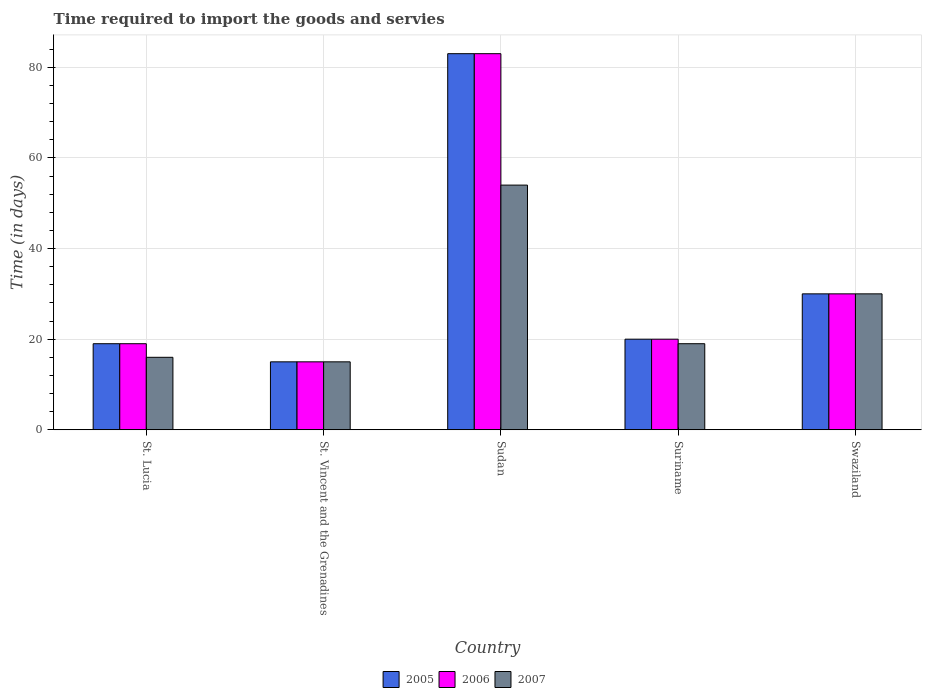How many groups of bars are there?
Your response must be concise. 5. Are the number of bars per tick equal to the number of legend labels?
Offer a very short reply. Yes. How many bars are there on the 5th tick from the left?
Your answer should be compact. 3. What is the label of the 1st group of bars from the left?
Offer a very short reply. St. Lucia. In how many cases, is the number of bars for a given country not equal to the number of legend labels?
Offer a very short reply. 0. What is the number of days required to import the goods and services in 2005 in Suriname?
Give a very brief answer. 20. In which country was the number of days required to import the goods and services in 2005 maximum?
Your answer should be very brief. Sudan. In which country was the number of days required to import the goods and services in 2005 minimum?
Ensure brevity in your answer.  St. Vincent and the Grenadines. What is the total number of days required to import the goods and services in 2006 in the graph?
Provide a succinct answer. 167. What is the difference between the number of days required to import the goods and services in 2006 in Suriname and that in Swaziland?
Give a very brief answer. -10. What is the difference between the number of days required to import the goods and services in 2005 in St. Lucia and the number of days required to import the goods and services in 2007 in Sudan?
Your answer should be compact. -35. What is the average number of days required to import the goods and services in 2005 per country?
Your answer should be compact. 33.4. What is the difference between the number of days required to import the goods and services of/in 2007 and number of days required to import the goods and services of/in 2005 in Sudan?
Your answer should be compact. -29. What is the ratio of the number of days required to import the goods and services in 2005 in St. Vincent and the Grenadines to that in Sudan?
Give a very brief answer. 0.18. Is the number of days required to import the goods and services in 2005 in Sudan less than that in Suriname?
Provide a short and direct response. No. Is the difference between the number of days required to import the goods and services in 2007 in Sudan and Swaziland greater than the difference between the number of days required to import the goods and services in 2005 in Sudan and Swaziland?
Keep it short and to the point. No. What is the difference between the highest and the lowest number of days required to import the goods and services in 2007?
Your answer should be compact. 39. In how many countries, is the number of days required to import the goods and services in 2007 greater than the average number of days required to import the goods and services in 2007 taken over all countries?
Your response must be concise. 2. Is the sum of the number of days required to import the goods and services in 2006 in St. Lucia and Suriname greater than the maximum number of days required to import the goods and services in 2005 across all countries?
Your answer should be compact. No. What does the 3rd bar from the right in Swaziland represents?
Keep it short and to the point. 2005. How many bars are there?
Offer a terse response. 15. Are all the bars in the graph horizontal?
Offer a very short reply. No. How many countries are there in the graph?
Provide a short and direct response. 5. Are the values on the major ticks of Y-axis written in scientific E-notation?
Make the answer very short. No. Does the graph contain any zero values?
Your answer should be compact. No. Where does the legend appear in the graph?
Give a very brief answer. Bottom center. How many legend labels are there?
Your answer should be compact. 3. How are the legend labels stacked?
Keep it short and to the point. Horizontal. What is the title of the graph?
Provide a short and direct response. Time required to import the goods and servies. What is the label or title of the X-axis?
Your answer should be compact. Country. What is the label or title of the Y-axis?
Keep it short and to the point. Time (in days). What is the Time (in days) of 2007 in St. Lucia?
Ensure brevity in your answer.  16. What is the Time (in days) in 2007 in St. Vincent and the Grenadines?
Ensure brevity in your answer.  15. What is the Time (in days) in 2007 in Sudan?
Offer a very short reply. 54. What is the Time (in days) of 2005 in Suriname?
Keep it short and to the point. 20. What is the Time (in days) in 2007 in Suriname?
Ensure brevity in your answer.  19. What is the Time (in days) in 2006 in Swaziland?
Your answer should be compact. 30. Across all countries, what is the maximum Time (in days) of 2005?
Your response must be concise. 83. Across all countries, what is the maximum Time (in days) of 2006?
Ensure brevity in your answer.  83. Across all countries, what is the minimum Time (in days) of 2006?
Make the answer very short. 15. Across all countries, what is the minimum Time (in days) in 2007?
Offer a terse response. 15. What is the total Time (in days) of 2005 in the graph?
Ensure brevity in your answer.  167. What is the total Time (in days) of 2006 in the graph?
Give a very brief answer. 167. What is the total Time (in days) in 2007 in the graph?
Make the answer very short. 134. What is the difference between the Time (in days) in 2005 in St. Lucia and that in Sudan?
Give a very brief answer. -64. What is the difference between the Time (in days) in 2006 in St. Lucia and that in Sudan?
Provide a succinct answer. -64. What is the difference between the Time (in days) in 2007 in St. Lucia and that in Sudan?
Your response must be concise. -38. What is the difference between the Time (in days) of 2005 in St. Lucia and that in Suriname?
Make the answer very short. -1. What is the difference between the Time (in days) of 2006 in St. Lucia and that in Suriname?
Your answer should be compact. -1. What is the difference between the Time (in days) of 2007 in St. Lucia and that in Swaziland?
Keep it short and to the point. -14. What is the difference between the Time (in days) in 2005 in St. Vincent and the Grenadines and that in Sudan?
Provide a succinct answer. -68. What is the difference between the Time (in days) of 2006 in St. Vincent and the Grenadines and that in Sudan?
Ensure brevity in your answer.  -68. What is the difference between the Time (in days) in 2007 in St. Vincent and the Grenadines and that in Sudan?
Keep it short and to the point. -39. What is the difference between the Time (in days) of 2006 in St. Vincent and the Grenadines and that in Suriname?
Keep it short and to the point. -5. What is the difference between the Time (in days) of 2007 in St. Vincent and the Grenadines and that in Suriname?
Give a very brief answer. -4. What is the difference between the Time (in days) in 2005 in St. Vincent and the Grenadines and that in Swaziland?
Offer a very short reply. -15. What is the difference between the Time (in days) in 2006 in St. Vincent and the Grenadines and that in Swaziland?
Offer a terse response. -15. What is the difference between the Time (in days) of 2005 in Sudan and that in Suriname?
Provide a short and direct response. 63. What is the difference between the Time (in days) in 2007 in Sudan and that in Suriname?
Give a very brief answer. 35. What is the difference between the Time (in days) in 2005 in Sudan and that in Swaziland?
Ensure brevity in your answer.  53. What is the difference between the Time (in days) in 2006 in Sudan and that in Swaziland?
Your answer should be very brief. 53. What is the difference between the Time (in days) of 2007 in Sudan and that in Swaziland?
Provide a succinct answer. 24. What is the difference between the Time (in days) in 2005 in Suriname and that in Swaziland?
Your answer should be very brief. -10. What is the difference between the Time (in days) of 2006 in Suriname and that in Swaziland?
Make the answer very short. -10. What is the difference between the Time (in days) of 2007 in Suriname and that in Swaziland?
Ensure brevity in your answer.  -11. What is the difference between the Time (in days) in 2005 in St. Lucia and the Time (in days) in 2006 in St. Vincent and the Grenadines?
Provide a succinct answer. 4. What is the difference between the Time (in days) of 2005 in St. Lucia and the Time (in days) of 2006 in Sudan?
Make the answer very short. -64. What is the difference between the Time (in days) of 2005 in St. Lucia and the Time (in days) of 2007 in Sudan?
Your answer should be compact. -35. What is the difference between the Time (in days) of 2006 in St. Lucia and the Time (in days) of 2007 in Sudan?
Make the answer very short. -35. What is the difference between the Time (in days) in 2005 in St. Lucia and the Time (in days) in 2006 in Suriname?
Your response must be concise. -1. What is the difference between the Time (in days) of 2005 in St. Lucia and the Time (in days) of 2007 in Suriname?
Offer a terse response. 0. What is the difference between the Time (in days) of 2005 in St. Lucia and the Time (in days) of 2006 in Swaziland?
Offer a terse response. -11. What is the difference between the Time (in days) of 2006 in St. Lucia and the Time (in days) of 2007 in Swaziland?
Offer a very short reply. -11. What is the difference between the Time (in days) of 2005 in St. Vincent and the Grenadines and the Time (in days) of 2006 in Sudan?
Offer a terse response. -68. What is the difference between the Time (in days) in 2005 in St. Vincent and the Grenadines and the Time (in days) in 2007 in Sudan?
Offer a terse response. -39. What is the difference between the Time (in days) of 2006 in St. Vincent and the Grenadines and the Time (in days) of 2007 in Sudan?
Offer a very short reply. -39. What is the difference between the Time (in days) in 2006 in St. Vincent and the Grenadines and the Time (in days) in 2007 in Suriname?
Offer a very short reply. -4. What is the difference between the Time (in days) in 2005 in St. Vincent and the Grenadines and the Time (in days) in 2006 in Swaziland?
Provide a succinct answer. -15. What is the difference between the Time (in days) in 2005 in St. Vincent and the Grenadines and the Time (in days) in 2007 in Swaziland?
Give a very brief answer. -15. What is the difference between the Time (in days) of 2005 in Sudan and the Time (in days) of 2007 in Suriname?
Your answer should be very brief. 64. What is the difference between the Time (in days) in 2005 in Sudan and the Time (in days) in 2006 in Swaziland?
Keep it short and to the point. 53. What is the difference between the Time (in days) in 2006 in Sudan and the Time (in days) in 2007 in Swaziland?
Give a very brief answer. 53. What is the difference between the Time (in days) of 2005 in Suriname and the Time (in days) of 2007 in Swaziland?
Give a very brief answer. -10. What is the difference between the Time (in days) in 2006 in Suriname and the Time (in days) in 2007 in Swaziland?
Your answer should be very brief. -10. What is the average Time (in days) in 2005 per country?
Give a very brief answer. 33.4. What is the average Time (in days) in 2006 per country?
Keep it short and to the point. 33.4. What is the average Time (in days) in 2007 per country?
Provide a succinct answer. 26.8. What is the difference between the Time (in days) of 2005 and Time (in days) of 2006 in St. Lucia?
Your answer should be compact. 0. What is the difference between the Time (in days) of 2005 and Time (in days) of 2007 in St. Lucia?
Your answer should be compact. 3. What is the difference between the Time (in days) in 2006 and Time (in days) in 2007 in St. Vincent and the Grenadines?
Keep it short and to the point. 0. What is the difference between the Time (in days) in 2005 and Time (in days) in 2006 in Sudan?
Your answer should be very brief. 0. What is the difference between the Time (in days) of 2005 and Time (in days) of 2007 in Sudan?
Your response must be concise. 29. What is the difference between the Time (in days) of 2006 and Time (in days) of 2007 in Sudan?
Make the answer very short. 29. What is the difference between the Time (in days) in 2005 and Time (in days) in 2006 in Suriname?
Ensure brevity in your answer.  0. What is the difference between the Time (in days) in 2006 and Time (in days) in 2007 in Suriname?
Provide a short and direct response. 1. What is the difference between the Time (in days) of 2006 and Time (in days) of 2007 in Swaziland?
Offer a very short reply. 0. What is the ratio of the Time (in days) of 2005 in St. Lucia to that in St. Vincent and the Grenadines?
Ensure brevity in your answer.  1.27. What is the ratio of the Time (in days) of 2006 in St. Lucia to that in St. Vincent and the Grenadines?
Provide a short and direct response. 1.27. What is the ratio of the Time (in days) in 2007 in St. Lucia to that in St. Vincent and the Grenadines?
Offer a terse response. 1.07. What is the ratio of the Time (in days) in 2005 in St. Lucia to that in Sudan?
Make the answer very short. 0.23. What is the ratio of the Time (in days) of 2006 in St. Lucia to that in Sudan?
Ensure brevity in your answer.  0.23. What is the ratio of the Time (in days) in 2007 in St. Lucia to that in Sudan?
Provide a short and direct response. 0.3. What is the ratio of the Time (in days) in 2005 in St. Lucia to that in Suriname?
Keep it short and to the point. 0.95. What is the ratio of the Time (in days) of 2007 in St. Lucia to that in Suriname?
Give a very brief answer. 0.84. What is the ratio of the Time (in days) in 2005 in St. Lucia to that in Swaziland?
Your answer should be very brief. 0.63. What is the ratio of the Time (in days) of 2006 in St. Lucia to that in Swaziland?
Provide a succinct answer. 0.63. What is the ratio of the Time (in days) in 2007 in St. Lucia to that in Swaziland?
Your answer should be very brief. 0.53. What is the ratio of the Time (in days) of 2005 in St. Vincent and the Grenadines to that in Sudan?
Give a very brief answer. 0.18. What is the ratio of the Time (in days) of 2006 in St. Vincent and the Grenadines to that in Sudan?
Provide a succinct answer. 0.18. What is the ratio of the Time (in days) in 2007 in St. Vincent and the Grenadines to that in Sudan?
Make the answer very short. 0.28. What is the ratio of the Time (in days) of 2005 in St. Vincent and the Grenadines to that in Suriname?
Your answer should be compact. 0.75. What is the ratio of the Time (in days) in 2006 in St. Vincent and the Grenadines to that in Suriname?
Your answer should be very brief. 0.75. What is the ratio of the Time (in days) of 2007 in St. Vincent and the Grenadines to that in Suriname?
Offer a very short reply. 0.79. What is the ratio of the Time (in days) in 2005 in St. Vincent and the Grenadines to that in Swaziland?
Ensure brevity in your answer.  0.5. What is the ratio of the Time (in days) of 2006 in St. Vincent and the Grenadines to that in Swaziland?
Give a very brief answer. 0.5. What is the ratio of the Time (in days) in 2005 in Sudan to that in Suriname?
Give a very brief answer. 4.15. What is the ratio of the Time (in days) of 2006 in Sudan to that in Suriname?
Your answer should be very brief. 4.15. What is the ratio of the Time (in days) of 2007 in Sudan to that in Suriname?
Your answer should be very brief. 2.84. What is the ratio of the Time (in days) in 2005 in Sudan to that in Swaziland?
Keep it short and to the point. 2.77. What is the ratio of the Time (in days) in 2006 in Sudan to that in Swaziland?
Your response must be concise. 2.77. What is the ratio of the Time (in days) of 2007 in Sudan to that in Swaziland?
Offer a very short reply. 1.8. What is the ratio of the Time (in days) in 2007 in Suriname to that in Swaziland?
Provide a short and direct response. 0.63. What is the difference between the highest and the second highest Time (in days) in 2006?
Provide a succinct answer. 53. What is the difference between the highest and the lowest Time (in days) of 2006?
Your answer should be compact. 68. 